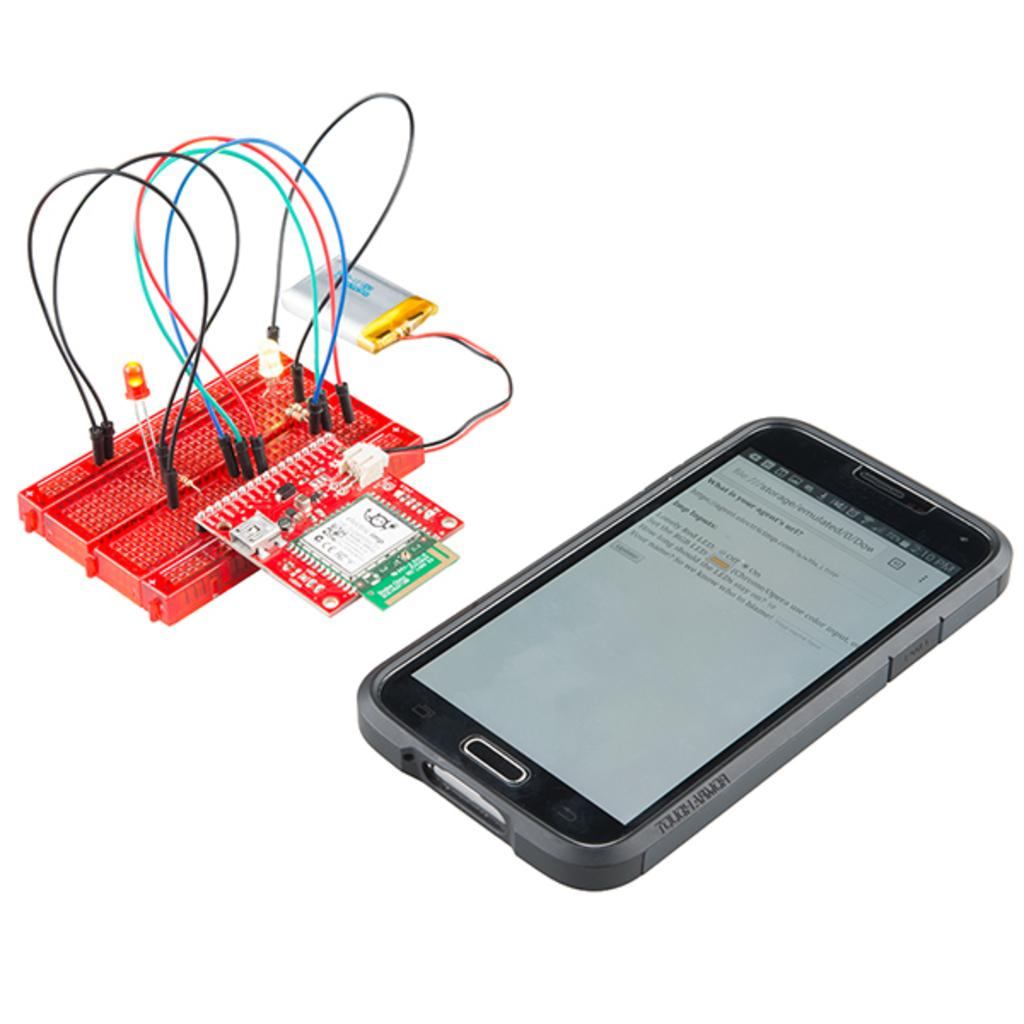<image>
Relay a brief, clear account of the picture shown. A phone with the time 2:10 P.M. and a circuit board. 